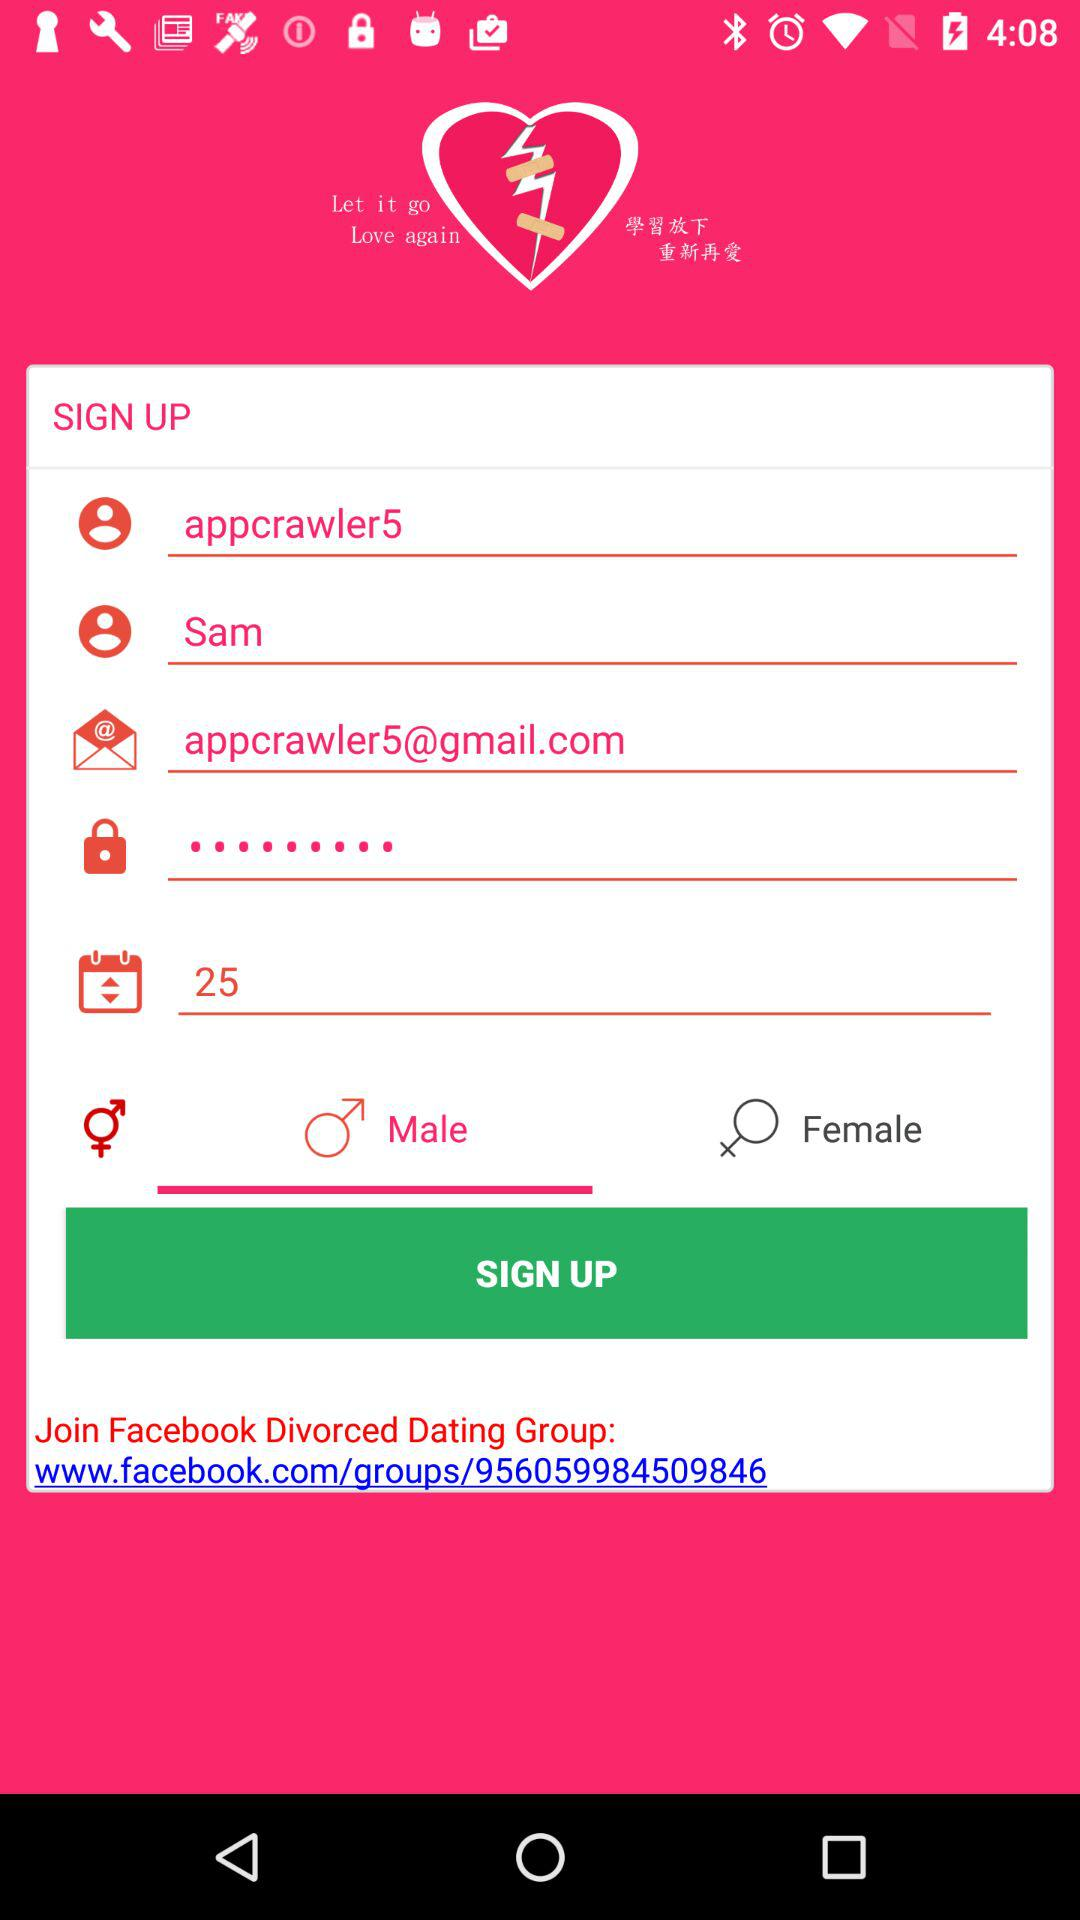What is the name? The name is Sam. 